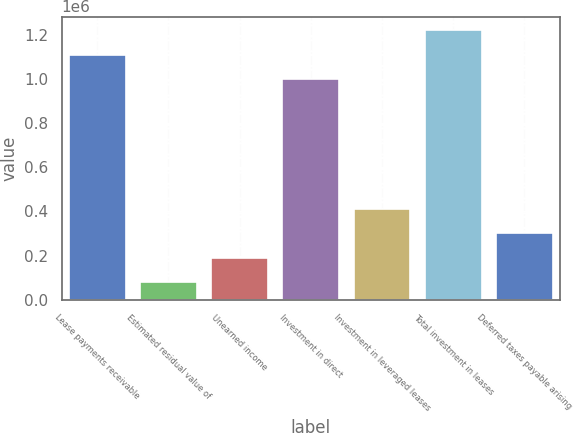Convert chart to OTSL. <chart><loc_0><loc_0><loc_500><loc_500><bar_chart><fcel>Lease payments receivable<fcel>Estimated residual value of<fcel>Unearned income<fcel>Investment in direct<fcel>Investment in leveraged leases<fcel>Total investment in leases<fcel>Deferred taxes payable arising<nl><fcel>1.10884e+06<fcel>79525<fcel>190486<fcel>997881<fcel>412409<fcel>1.2198e+06<fcel>301448<nl></chart> 